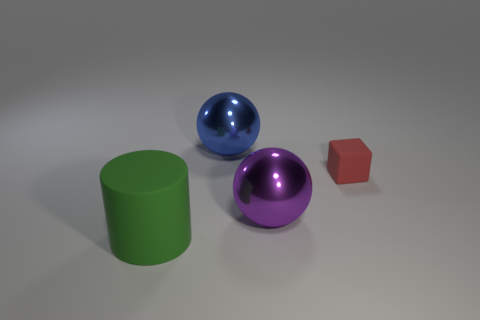Can you tell me what objects are shown in the image and what colors they are? Certainly! The image displays four objects: a large purple sphere, a slightly smaller blue sphere, a green cylinder, and a small red cube. 